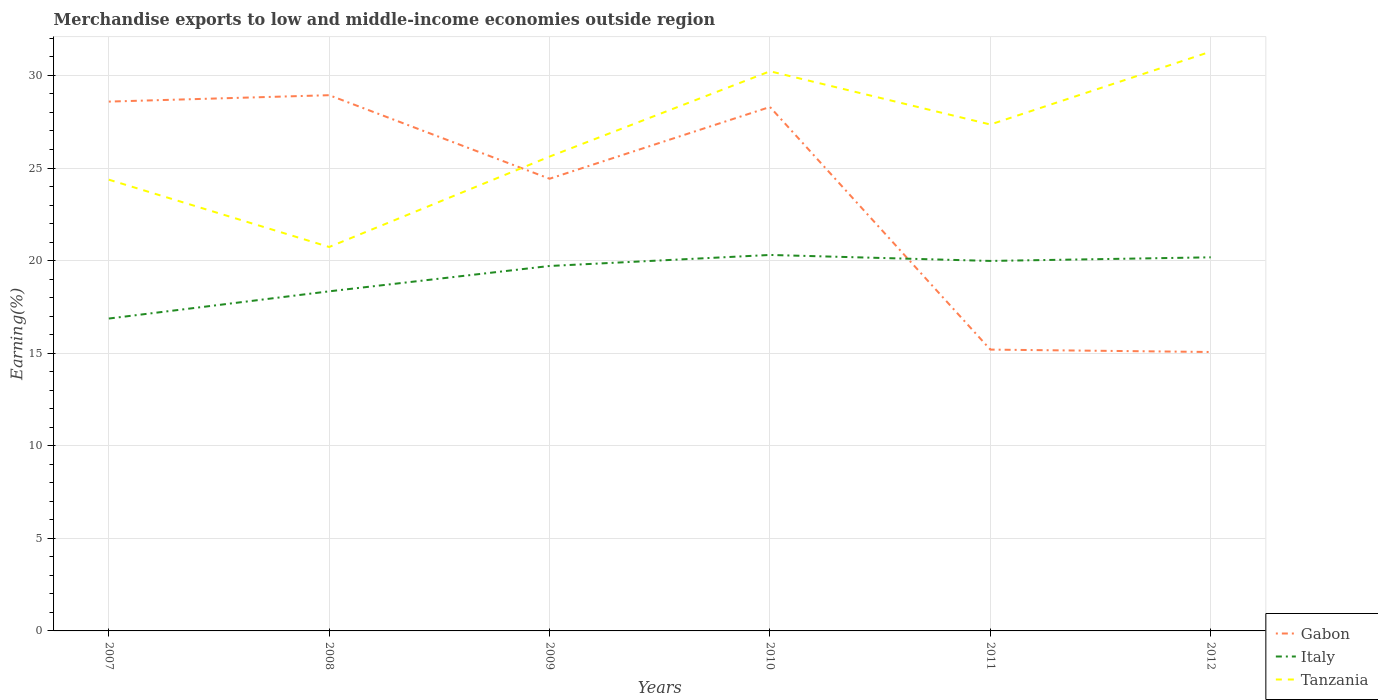Does the line corresponding to Gabon intersect with the line corresponding to Italy?
Your response must be concise. Yes. Across all years, what is the maximum percentage of amount earned from merchandise exports in Tanzania?
Keep it short and to the point. 20.74. What is the total percentage of amount earned from merchandise exports in Italy in the graph?
Offer a very short reply. -0.6. What is the difference between the highest and the second highest percentage of amount earned from merchandise exports in Gabon?
Provide a succinct answer. 13.87. What is the difference between the highest and the lowest percentage of amount earned from merchandise exports in Tanzania?
Make the answer very short. 3. Is the percentage of amount earned from merchandise exports in Tanzania strictly greater than the percentage of amount earned from merchandise exports in Italy over the years?
Make the answer very short. No. How many lines are there?
Keep it short and to the point. 3. Are the values on the major ticks of Y-axis written in scientific E-notation?
Your answer should be very brief. No. How are the legend labels stacked?
Provide a short and direct response. Vertical. What is the title of the graph?
Your response must be concise. Merchandise exports to low and middle-income economies outside region. What is the label or title of the X-axis?
Make the answer very short. Years. What is the label or title of the Y-axis?
Your answer should be compact. Earning(%). What is the Earning(%) of Gabon in 2007?
Provide a succinct answer. 28.59. What is the Earning(%) in Italy in 2007?
Give a very brief answer. 16.87. What is the Earning(%) in Tanzania in 2007?
Your response must be concise. 24.37. What is the Earning(%) of Gabon in 2008?
Provide a succinct answer. 28.93. What is the Earning(%) in Italy in 2008?
Make the answer very short. 18.34. What is the Earning(%) of Tanzania in 2008?
Keep it short and to the point. 20.74. What is the Earning(%) of Gabon in 2009?
Keep it short and to the point. 24.42. What is the Earning(%) of Italy in 2009?
Provide a short and direct response. 19.71. What is the Earning(%) of Tanzania in 2009?
Your answer should be compact. 25.62. What is the Earning(%) of Gabon in 2010?
Ensure brevity in your answer.  28.3. What is the Earning(%) in Italy in 2010?
Your answer should be compact. 20.3. What is the Earning(%) in Tanzania in 2010?
Offer a very short reply. 30.23. What is the Earning(%) of Gabon in 2011?
Your response must be concise. 15.19. What is the Earning(%) in Italy in 2011?
Give a very brief answer. 19.98. What is the Earning(%) in Tanzania in 2011?
Make the answer very short. 27.35. What is the Earning(%) of Gabon in 2012?
Provide a short and direct response. 15.06. What is the Earning(%) in Italy in 2012?
Keep it short and to the point. 20.18. What is the Earning(%) of Tanzania in 2012?
Ensure brevity in your answer.  31.29. Across all years, what is the maximum Earning(%) of Gabon?
Keep it short and to the point. 28.93. Across all years, what is the maximum Earning(%) of Italy?
Your answer should be compact. 20.3. Across all years, what is the maximum Earning(%) in Tanzania?
Keep it short and to the point. 31.29. Across all years, what is the minimum Earning(%) of Gabon?
Offer a very short reply. 15.06. Across all years, what is the minimum Earning(%) of Italy?
Ensure brevity in your answer.  16.87. Across all years, what is the minimum Earning(%) in Tanzania?
Make the answer very short. 20.74. What is the total Earning(%) in Gabon in the graph?
Your answer should be very brief. 140.5. What is the total Earning(%) in Italy in the graph?
Your response must be concise. 115.39. What is the total Earning(%) in Tanzania in the graph?
Your answer should be compact. 159.59. What is the difference between the Earning(%) in Gabon in 2007 and that in 2008?
Provide a succinct answer. -0.35. What is the difference between the Earning(%) of Italy in 2007 and that in 2008?
Give a very brief answer. -1.47. What is the difference between the Earning(%) in Tanzania in 2007 and that in 2008?
Make the answer very short. 3.64. What is the difference between the Earning(%) in Gabon in 2007 and that in 2009?
Your answer should be very brief. 4.17. What is the difference between the Earning(%) of Italy in 2007 and that in 2009?
Your answer should be compact. -2.84. What is the difference between the Earning(%) of Tanzania in 2007 and that in 2009?
Keep it short and to the point. -1.25. What is the difference between the Earning(%) in Gabon in 2007 and that in 2010?
Ensure brevity in your answer.  0.29. What is the difference between the Earning(%) of Italy in 2007 and that in 2010?
Your response must be concise. -3.43. What is the difference between the Earning(%) of Tanzania in 2007 and that in 2010?
Offer a terse response. -5.85. What is the difference between the Earning(%) in Gabon in 2007 and that in 2011?
Your response must be concise. 13.39. What is the difference between the Earning(%) of Italy in 2007 and that in 2011?
Your answer should be compact. -3.11. What is the difference between the Earning(%) in Tanzania in 2007 and that in 2011?
Provide a succinct answer. -2.98. What is the difference between the Earning(%) in Gabon in 2007 and that in 2012?
Give a very brief answer. 13.52. What is the difference between the Earning(%) in Italy in 2007 and that in 2012?
Offer a terse response. -3.31. What is the difference between the Earning(%) in Tanzania in 2007 and that in 2012?
Give a very brief answer. -6.92. What is the difference between the Earning(%) in Gabon in 2008 and that in 2009?
Keep it short and to the point. 4.51. What is the difference between the Earning(%) of Italy in 2008 and that in 2009?
Keep it short and to the point. -1.37. What is the difference between the Earning(%) of Tanzania in 2008 and that in 2009?
Provide a succinct answer. -4.88. What is the difference between the Earning(%) in Gabon in 2008 and that in 2010?
Your response must be concise. 0.64. What is the difference between the Earning(%) of Italy in 2008 and that in 2010?
Offer a terse response. -1.96. What is the difference between the Earning(%) in Tanzania in 2008 and that in 2010?
Your answer should be compact. -9.49. What is the difference between the Earning(%) of Gabon in 2008 and that in 2011?
Make the answer very short. 13.74. What is the difference between the Earning(%) in Italy in 2008 and that in 2011?
Give a very brief answer. -1.64. What is the difference between the Earning(%) in Tanzania in 2008 and that in 2011?
Provide a short and direct response. -6.61. What is the difference between the Earning(%) of Gabon in 2008 and that in 2012?
Your response must be concise. 13.87. What is the difference between the Earning(%) in Italy in 2008 and that in 2012?
Your response must be concise. -1.84. What is the difference between the Earning(%) in Tanzania in 2008 and that in 2012?
Provide a short and direct response. -10.55. What is the difference between the Earning(%) of Gabon in 2009 and that in 2010?
Make the answer very short. -3.88. What is the difference between the Earning(%) in Italy in 2009 and that in 2010?
Provide a succinct answer. -0.6. What is the difference between the Earning(%) in Tanzania in 2009 and that in 2010?
Your answer should be compact. -4.61. What is the difference between the Earning(%) in Gabon in 2009 and that in 2011?
Your answer should be compact. 9.23. What is the difference between the Earning(%) of Italy in 2009 and that in 2011?
Make the answer very short. -0.27. What is the difference between the Earning(%) of Tanzania in 2009 and that in 2011?
Make the answer very short. -1.73. What is the difference between the Earning(%) of Gabon in 2009 and that in 2012?
Offer a very short reply. 9.36. What is the difference between the Earning(%) of Italy in 2009 and that in 2012?
Your answer should be very brief. -0.47. What is the difference between the Earning(%) of Tanzania in 2009 and that in 2012?
Provide a short and direct response. -5.67. What is the difference between the Earning(%) of Gabon in 2010 and that in 2011?
Make the answer very short. 13.1. What is the difference between the Earning(%) in Italy in 2010 and that in 2011?
Offer a very short reply. 0.32. What is the difference between the Earning(%) of Tanzania in 2010 and that in 2011?
Offer a very short reply. 2.88. What is the difference between the Earning(%) of Gabon in 2010 and that in 2012?
Offer a terse response. 13.23. What is the difference between the Earning(%) of Italy in 2010 and that in 2012?
Keep it short and to the point. 0.13. What is the difference between the Earning(%) in Tanzania in 2010 and that in 2012?
Provide a succinct answer. -1.06. What is the difference between the Earning(%) in Gabon in 2011 and that in 2012?
Offer a very short reply. 0.13. What is the difference between the Earning(%) in Italy in 2011 and that in 2012?
Provide a succinct answer. -0.19. What is the difference between the Earning(%) of Tanzania in 2011 and that in 2012?
Offer a very short reply. -3.94. What is the difference between the Earning(%) in Gabon in 2007 and the Earning(%) in Italy in 2008?
Your answer should be compact. 10.25. What is the difference between the Earning(%) of Gabon in 2007 and the Earning(%) of Tanzania in 2008?
Offer a very short reply. 7.85. What is the difference between the Earning(%) in Italy in 2007 and the Earning(%) in Tanzania in 2008?
Your answer should be very brief. -3.86. What is the difference between the Earning(%) of Gabon in 2007 and the Earning(%) of Italy in 2009?
Keep it short and to the point. 8.88. What is the difference between the Earning(%) in Gabon in 2007 and the Earning(%) in Tanzania in 2009?
Your answer should be compact. 2.97. What is the difference between the Earning(%) in Italy in 2007 and the Earning(%) in Tanzania in 2009?
Offer a terse response. -8.75. What is the difference between the Earning(%) in Gabon in 2007 and the Earning(%) in Italy in 2010?
Your response must be concise. 8.28. What is the difference between the Earning(%) of Gabon in 2007 and the Earning(%) of Tanzania in 2010?
Ensure brevity in your answer.  -1.64. What is the difference between the Earning(%) of Italy in 2007 and the Earning(%) of Tanzania in 2010?
Your answer should be very brief. -13.35. What is the difference between the Earning(%) of Gabon in 2007 and the Earning(%) of Italy in 2011?
Your answer should be compact. 8.6. What is the difference between the Earning(%) of Gabon in 2007 and the Earning(%) of Tanzania in 2011?
Provide a succinct answer. 1.24. What is the difference between the Earning(%) of Italy in 2007 and the Earning(%) of Tanzania in 2011?
Your answer should be very brief. -10.48. What is the difference between the Earning(%) in Gabon in 2007 and the Earning(%) in Italy in 2012?
Provide a succinct answer. 8.41. What is the difference between the Earning(%) in Gabon in 2007 and the Earning(%) in Tanzania in 2012?
Your answer should be very brief. -2.7. What is the difference between the Earning(%) in Italy in 2007 and the Earning(%) in Tanzania in 2012?
Provide a short and direct response. -14.42. What is the difference between the Earning(%) of Gabon in 2008 and the Earning(%) of Italy in 2009?
Ensure brevity in your answer.  9.22. What is the difference between the Earning(%) of Gabon in 2008 and the Earning(%) of Tanzania in 2009?
Offer a terse response. 3.32. What is the difference between the Earning(%) of Italy in 2008 and the Earning(%) of Tanzania in 2009?
Ensure brevity in your answer.  -7.28. What is the difference between the Earning(%) of Gabon in 2008 and the Earning(%) of Italy in 2010?
Offer a terse response. 8.63. What is the difference between the Earning(%) in Gabon in 2008 and the Earning(%) in Tanzania in 2010?
Provide a succinct answer. -1.29. What is the difference between the Earning(%) in Italy in 2008 and the Earning(%) in Tanzania in 2010?
Make the answer very short. -11.88. What is the difference between the Earning(%) in Gabon in 2008 and the Earning(%) in Italy in 2011?
Offer a terse response. 8.95. What is the difference between the Earning(%) of Gabon in 2008 and the Earning(%) of Tanzania in 2011?
Offer a very short reply. 1.58. What is the difference between the Earning(%) of Italy in 2008 and the Earning(%) of Tanzania in 2011?
Ensure brevity in your answer.  -9.01. What is the difference between the Earning(%) of Gabon in 2008 and the Earning(%) of Italy in 2012?
Ensure brevity in your answer.  8.76. What is the difference between the Earning(%) in Gabon in 2008 and the Earning(%) in Tanzania in 2012?
Your response must be concise. -2.35. What is the difference between the Earning(%) in Italy in 2008 and the Earning(%) in Tanzania in 2012?
Keep it short and to the point. -12.95. What is the difference between the Earning(%) of Gabon in 2009 and the Earning(%) of Italy in 2010?
Offer a terse response. 4.12. What is the difference between the Earning(%) of Gabon in 2009 and the Earning(%) of Tanzania in 2010?
Keep it short and to the point. -5.8. What is the difference between the Earning(%) in Italy in 2009 and the Earning(%) in Tanzania in 2010?
Keep it short and to the point. -10.52. What is the difference between the Earning(%) of Gabon in 2009 and the Earning(%) of Italy in 2011?
Ensure brevity in your answer.  4.44. What is the difference between the Earning(%) of Gabon in 2009 and the Earning(%) of Tanzania in 2011?
Ensure brevity in your answer.  -2.93. What is the difference between the Earning(%) in Italy in 2009 and the Earning(%) in Tanzania in 2011?
Make the answer very short. -7.64. What is the difference between the Earning(%) of Gabon in 2009 and the Earning(%) of Italy in 2012?
Offer a very short reply. 4.24. What is the difference between the Earning(%) in Gabon in 2009 and the Earning(%) in Tanzania in 2012?
Give a very brief answer. -6.87. What is the difference between the Earning(%) in Italy in 2009 and the Earning(%) in Tanzania in 2012?
Offer a terse response. -11.58. What is the difference between the Earning(%) of Gabon in 2010 and the Earning(%) of Italy in 2011?
Your response must be concise. 8.31. What is the difference between the Earning(%) in Italy in 2010 and the Earning(%) in Tanzania in 2011?
Provide a succinct answer. -7.04. What is the difference between the Earning(%) of Gabon in 2010 and the Earning(%) of Italy in 2012?
Your answer should be very brief. 8.12. What is the difference between the Earning(%) in Gabon in 2010 and the Earning(%) in Tanzania in 2012?
Your answer should be very brief. -2.99. What is the difference between the Earning(%) in Italy in 2010 and the Earning(%) in Tanzania in 2012?
Give a very brief answer. -10.98. What is the difference between the Earning(%) in Gabon in 2011 and the Earning(%) in Italy in 2012?
Offer a terse response. -4.98. What is the difference between the Earning(%) in Gabon in 2011 and the Earning(%) in Tanzania in 2012?
Ensure brevity in your answer.  -16.09. What is the difference between the Earning(%) in Italy in 2011 and the Earning(%) in Tanzania in 2012?
Your answer should be very brief. -11.31. What is the average Earning(%) of Gabon per year?
Your answer should be compact. 23.42. What is the average Earning(%) of Italy per year?
Provide a short and direct response. 19.23. What is the average Earning(%) in Tanzania per year?
Offer a very short reply. 26.6. In the year 2007, what is the difference between the Earning(%) of Gabon and Earning(%) of Italy?
Ensure brevity in your answer.  11.72. In the year 2007, what is the difference between the Earning(%) in Gabon and Earning(%) in Tanzania?
Ensure brevity in your answer.  4.22. In the year 2007, what is the difference between the Earning(%) in Italy and Earning(%) in Tanzania?
Ensure brevity in your answer.  -7.5. In the year 2008, what is the difference between the Earning(%) of Gabon and Earning(%) of Italy?
Provide a succinct answer. 10.59. In the year 2008, what is the difference between the Earning(%) in Gabon and Earning(%) in Tanzania?
Provide a succinct answer. 8.2. In the year 2008, what is the difference between the Earning(%) in Italy and Earning(%) in Tanzania?
Your response must be concise. -2.39. In the year 2009, what is the difference between the Earning(%) in Gabon and Earning(%) in Italy?
Provide a short and direct response. 4.71. In the year 2009, what is the difference between the Earning(%) of Gabon and Earning(%) of Tanzania?
Your answer should be very brief. -1.2. In the year 2009, what is the difference between the Earning(%) in Italy and Earning(%) in Tanzania?
Make the answer very short. -5.91. In the year 2010, what is the difference between the Earning(%) of Gabon and Earning(%) of Italy?
Provide a succinct answer. 7.99. In the year 2010, what is the difference between the Earning(%) of Gabon and Earning(%) of Tanzania?
Your answer should be compact. -1.93. In the year 2010, what is the difference between the Earning(%) of Italy and Earning(%) of Tanzania?
Give a very brief answer. -9.92. In the year 2011, what is the difference between the Earning(%) of Gabon and Earning(%) of Italy?
Your answer should be compact. -4.79. In the year 2011, what is the difference between the Earning(%) in Gabon and Earning(%) in Tanzania?
Give a very brief answer. -12.16. In the year 2011, what is the difference between the Earning(%) in Italy and Earning(%) in Tanzania?
Keep it short and to the point. -7.37. In the year 2012, what is the difference between the Earning(%) of Gabon and Earning(%) of Italy?
Offer a terse response. -5.11. In the year 2012, what is the difference between the Earning(%) of Gabon and Earning(%) of Tanzania?
Provide a short and direct response. -16.22. In the year 2012, what is the difference between the Earning(%) in Italy and Earning(%) in Tanzania?
Offer a very short reply. -11.11. What is the ratio of the Earning(%) in Gabon in 2007 to that in 2008?
Your answer should be compact. 0.99. What is the ratio of the Earning(%) of Italy in 2007 to that in 2008?
Make the answer very short. 0.92. What is the ratio of the Earning(%) in Tanzania in 2007 to that in 2008?
Your answer should be compact. 1.18. What is the ratio of the Earning(%) in Gabon in 2007 to that in 2009?
Provide a short and direct response. 1.17. What is the ratio of the Earning(%) in Italy in 2007 to that in 2009?
Ensure brevity in your answer.  0.86. What is the ratio of the Earning(%) of Tanzania in 2007 to that in 2009?
Provide a succinct answer. 0.95. What is the ratio of the Earning(%) in Gabon in 2007 to that in 2010?
Provide a short and direct response. 1.01. What is the ratio of the Earning(%) in Italy in 2007 to that in 2010?
Your answer should be very brief. 0.83. What is the ratio of the Earning(%) of Tanzania in 2007 to that in 2010?
Provide a succinct answer. 0.81. What is the ratio of the Earning(%) in Gabon in 2007 to that in 2011?
Keep it short and to the point. 1.88. What is the ratio of the Earning(%) in Italy in 2007 to that in 2011?
Offer a very short reply. 0.84. What is the ratio of the Earning(%) in Tanzania in 2007 to that in 2011?
Ensure brevity in your answer.  0.89. What is the ratio of the Earning(%) of Gabon in 2007 to that in 2012?
Give a very brief answer. 1.9. What is the ratio of the Earning(%) of Italy in 2007 to that in 2012?
Your response must be concise. 0.84. What is the ratio of the Earning(%) in Tanzania in 2007 to that in 2012?
Your response must be concise. 0.78. What is the ratio of the Earning(%) of Gabon in 2008 to that in 2009?
Provide a short and direct response. 1.18. What is the ratio of the Earning(%) in Italy in 2008 to that in 2009?
Provide a short and direct response. 0.93. What is the ratio of the Earning(%) in Tanzania in 2008 to that in 2009?
Ensure brevity in your answer.  0.81. What is the ratio of the Earning(%) in Gabon in 2008 to that in 2010?
Ensure brevity in your answer.  1.02. What is the ratio of the Earning(%) of Italy in 2008 to that in 2010?
Your answer should be very brief. 0.9. What is the ratio of the Earning(%) of Tanzania in 2008 to that in 2010?
Make the answer very short. 0.69. What is the ratio of the Earning(%) in Gabon in 2008 to that in 2011?
Your response must be concise. 1.9. What is the ratio of the Earning(%) of Italy in 2008 to that in 2011?
Provide a short and direct response. 0.92. What is the ratio of the Earning(%) in Tanzania in 2008 to that in 2011?
Offer a terse response. 0.76. What is the ratio of the Earning(%) of Gabon in 2008 to that in 2012?
Give a very brief answer. 1.92. What is the ratio of the Earning(%) in Italy in 2008 to that in 2012?
Ensure brevity in your answer.  0.91. What is the ratio of the Earning(%) in Tanzania in 2008 to that in 2012?
Your response must be concise. 0.66. What is the ratio of the Earning(%) of Gabon in 2009 to that in 2010?
Provide a succinct answer. 0.86. What is the ratio of the Earning(%) in Italy in 2009 to that in 2010?
Give a very brief answer. 0.97. What is the ratio of the Earning(%) of Tanzania in 2009 to that in 2010?
Offer a very short reply. 0.85. What is the ratio of the Earning(%) in Gabon in 2009 to that in 2011?
Provide a succinct answer. 1.61. What is the ratio of the Earning(%) in Italy in 2009 to that in 2011?
Provide a succinct answer. 0.99. What is the ratio of the Earning(%) of Tanzania in 2009 to that in 2011?
Ensure brevity in your answer.  0.94. What is the ratio of the Earning(%) of Gabon in 2009 to that in 2012?
Ensure brevity in your answer.  1.62. What is the ratio of the Earning(%) in Italy in 2009 to that in 2012?
Offer a terse response. 0.98. What is the ratio of the Earning(%) of Tanzania in 2009 to that in 2012?
Ensure brevity in your answer.  0.82. What is the ratio of the Earning(%) in Gabon in 2010 to that in 2011?
Provide a succinct answer. 1.86. What is the ratio of the Earning(%) in Italy in 2010 to that in 2011?
Offer a very short reply. 1.02. What is the ratio of the Earning(%) of Tanzania in 2010 to that in 2011?
Keep it short and to the point. 1.11. What is the ratio of the Earning(%) in Gabon in 2010 to that in 2012?
Offer a very short reply. 1.88. What is the ratio of the Earning(%) of Gabon in 2011 to that in 2012?
Ensure brevity in your answer.  1.01. What is the ratio of the Earning(%) in Italy in 2011 to that in 2012?
Your answer should be compact. 0.99. What is the ratio of the Earning(%) in Tanzania in 2011 to that in 2012?
Keep it short and to the point. 0.87. What is the difference between the highest and the second highest Earning(%) of Gabon?
Provide a succinct answer. 0.35. What is the difference between the highest and the second highest Earning(%) in Italy?
Keep it short and to the point. 0.13. What is the difference between the highest and the second highest Earning(%) in Tanzania?
Your answer should be very brief. 1.06. What is the difference between the highest and the lowest Earning(%) of Gabon?
Your answer should be very brief. 13.87. What is the difference between the highest and the lowest Earning(%) in Italy?
Your response must be concise. 3.43. What is the difference between the highest and the lowest Earning(%) in Tanzania?
Make the answer very short. 10.55. 